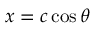Convert formula to latex. <formula><loc_0><loc_0><loc_500><loc_500>x = c \cos \theta</formula> 